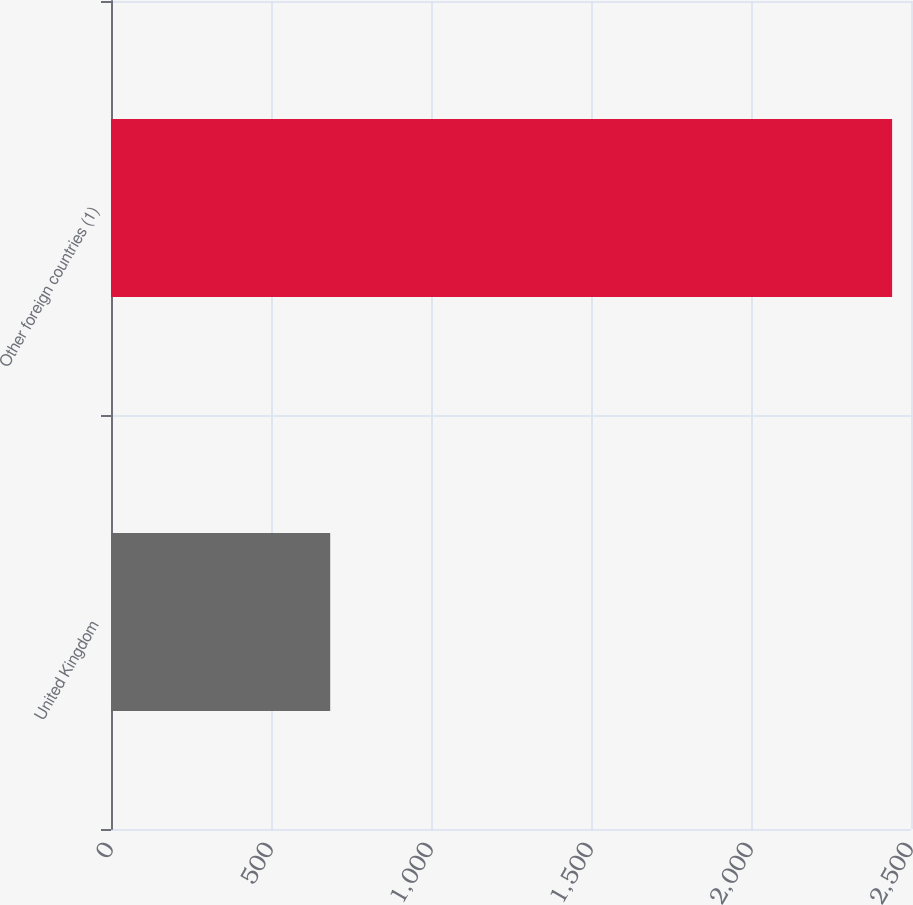Convert chart to OTSL. <chart><loc_0><loc_0><loc_500><loc_500><bar_chart><fcel>United Kingdom<fcel>Other foreign countries (1)<nl><fcel>685<fcel>2441<nl></chart> 